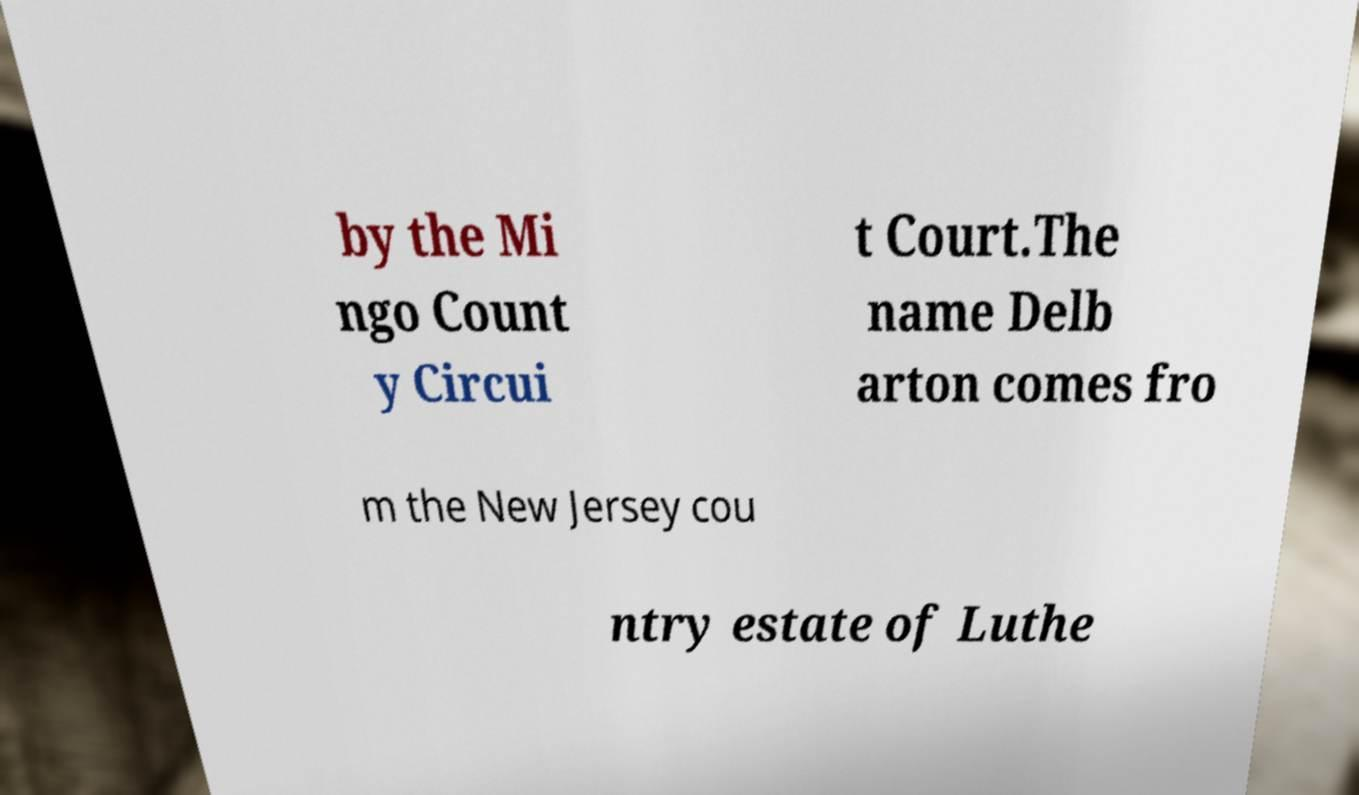What messages or text are displayed in this image? I need them in a readable, typed format. by the Mi ngo Count y Circui t Court.The name Delb arton comes fro m the New Jersey cou ntry estate of Luthe 